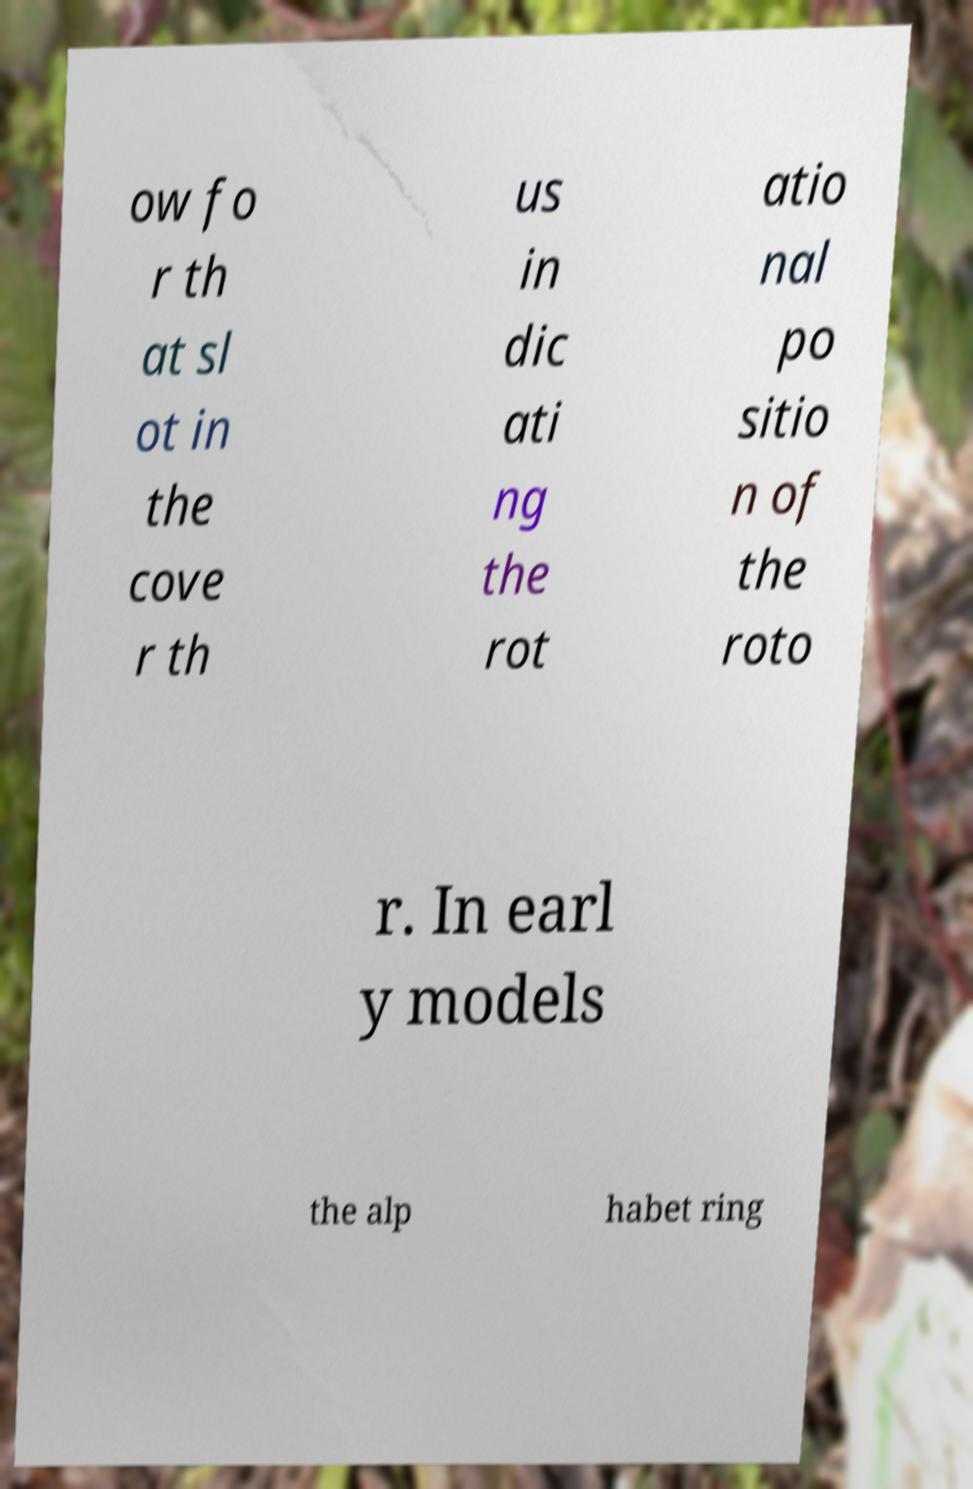Please read and relay the text visible in this image. What does it say? ow fo r th at sl ot in the cove r th us in dic ati ng the rot atio nal po sitio n of the roto r. In earl y models the alp habet ring 